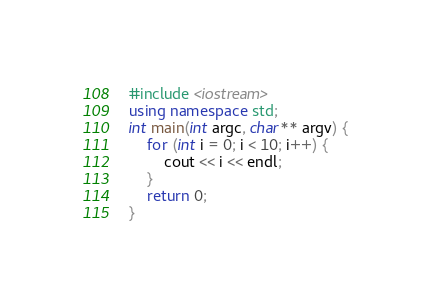<code> <loc_0><loc_0><loc_500><loc_500><_C++_>#include <iostream>
using namespace std;
int main(int argc, char** argv) {
	for (int i = 0; i < 10; i++) {
		cout << i << endl;
	}
	return 0;
}

</code> 